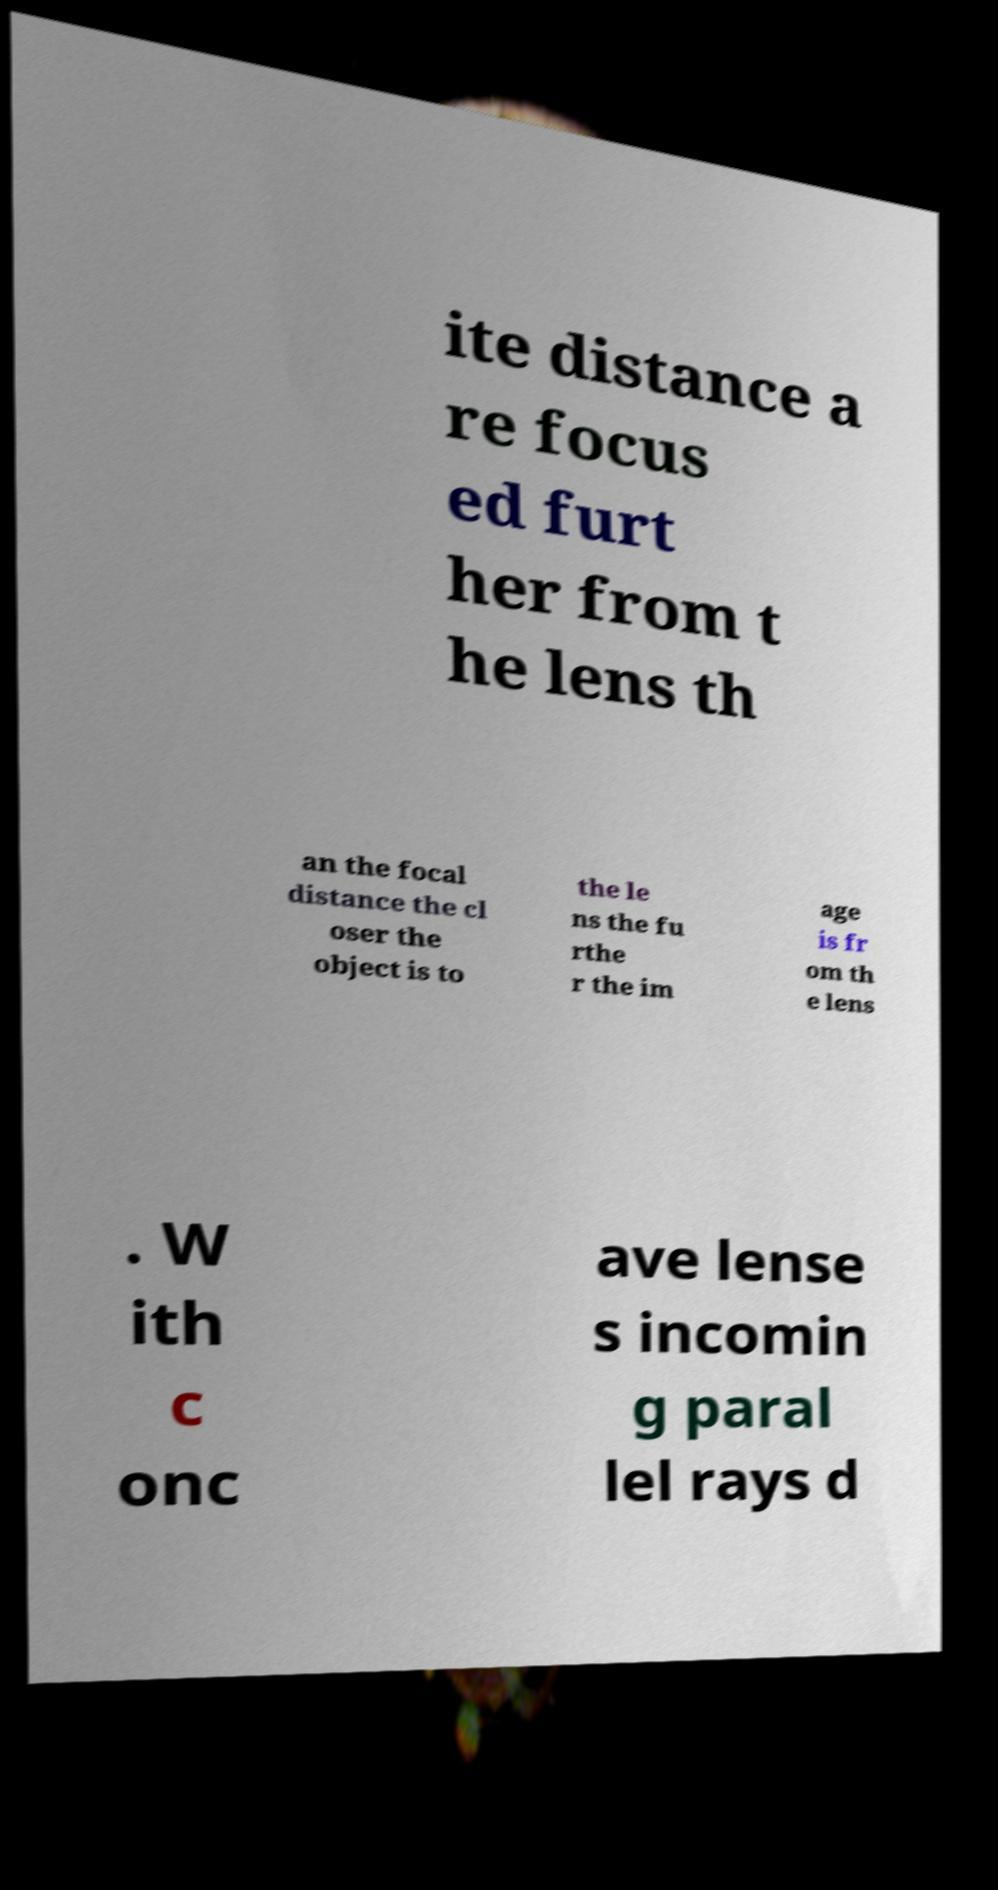Could you extract and type out the text from this image? ite distance a re focus ed furt her from t he lens th an the focal distance the cl oser the object is to the le ns the fu rthe r the im age is fr om th e lens . W ith c onc ave lense s incomin g paral lel rays d 